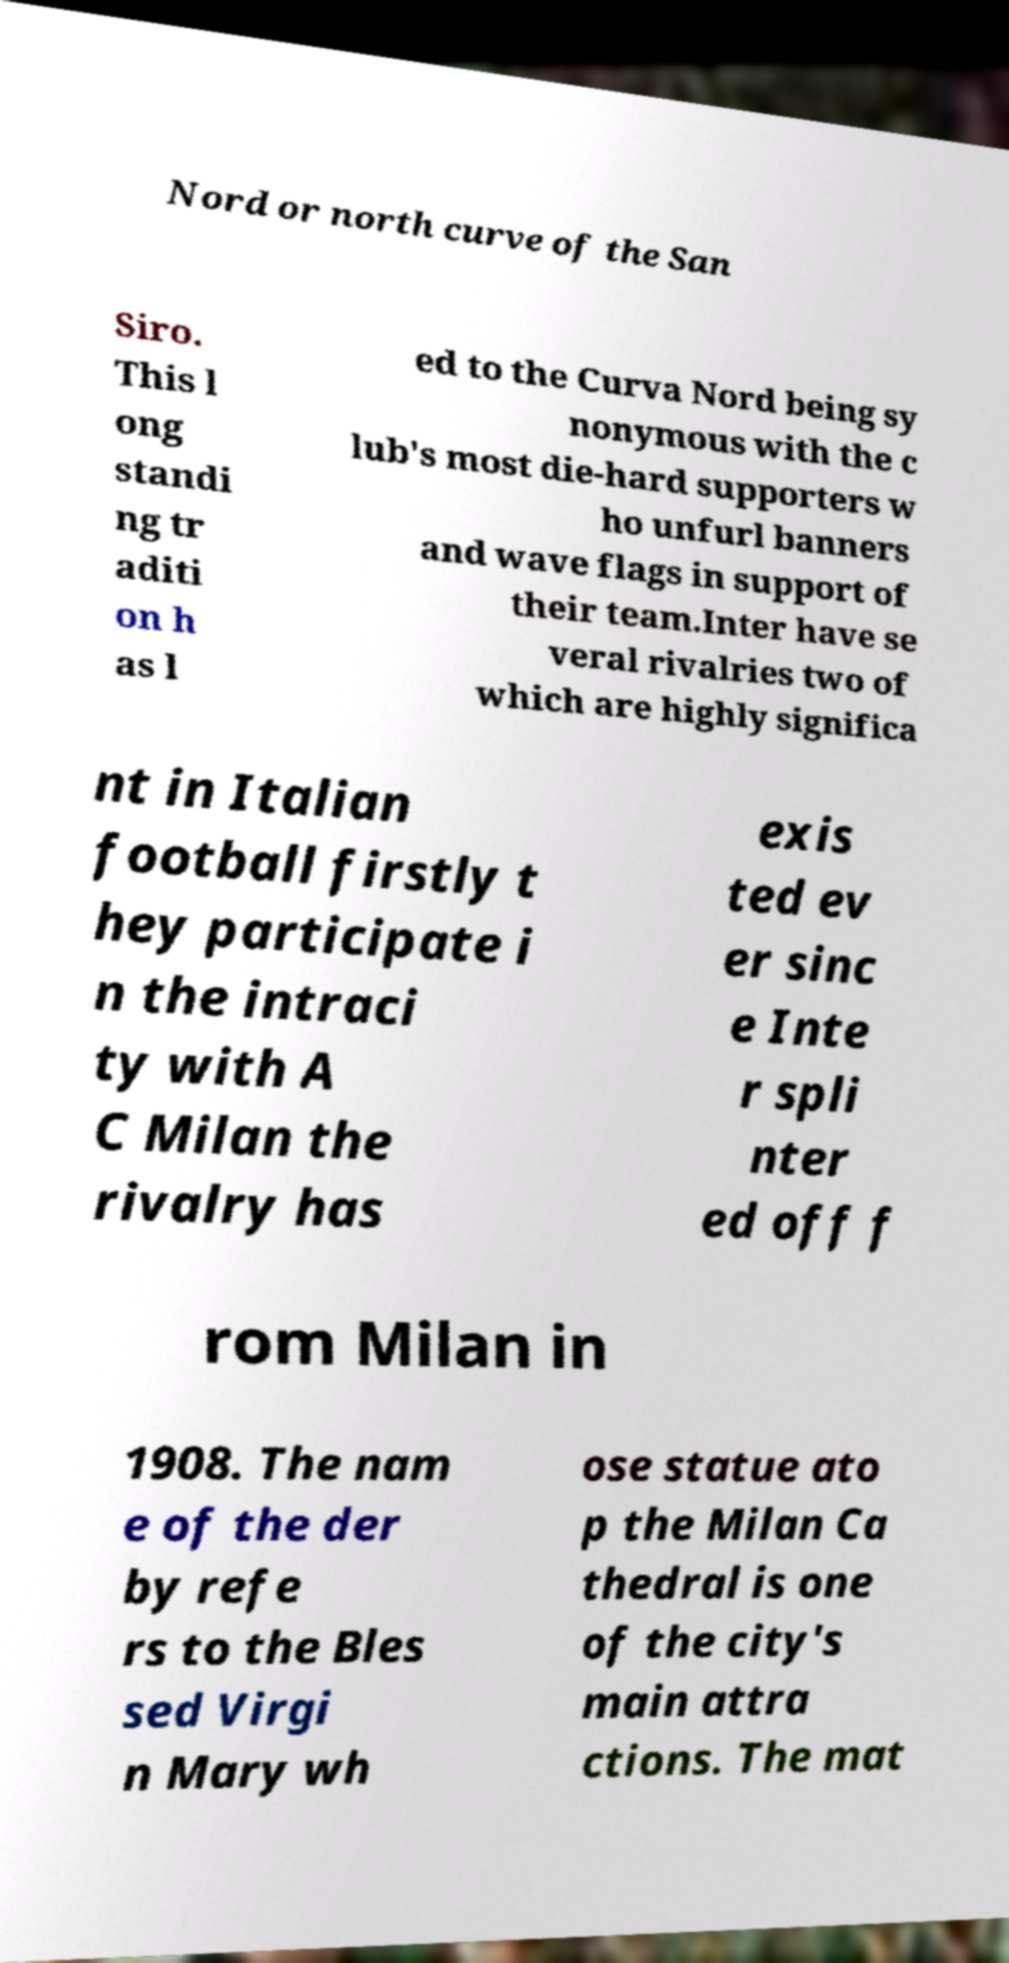Please read and relay the text visible in this image. What does it say? Nord or north curve of the San Siro. This l ong standi ng tr aditi on h as l ed to the Curva Nord being sy nonymous with the c lub's most die-hard supporters w ho unfurl banners and wave flags in support of their team.Inter have se veral rivalries two of which are highly significa nt in Italian football firstly t hey participate i n the intraci ty with A C Milan the rivalry has exis ted ev er sinc e Inte r spli nter ed off f rom Milan in 1908. The nam e of the der by refe rs to the Bles sed Virgi n Mary wh ose statue ato p the Milan Ca thedral is one of the city's main attra ctions. The mat 